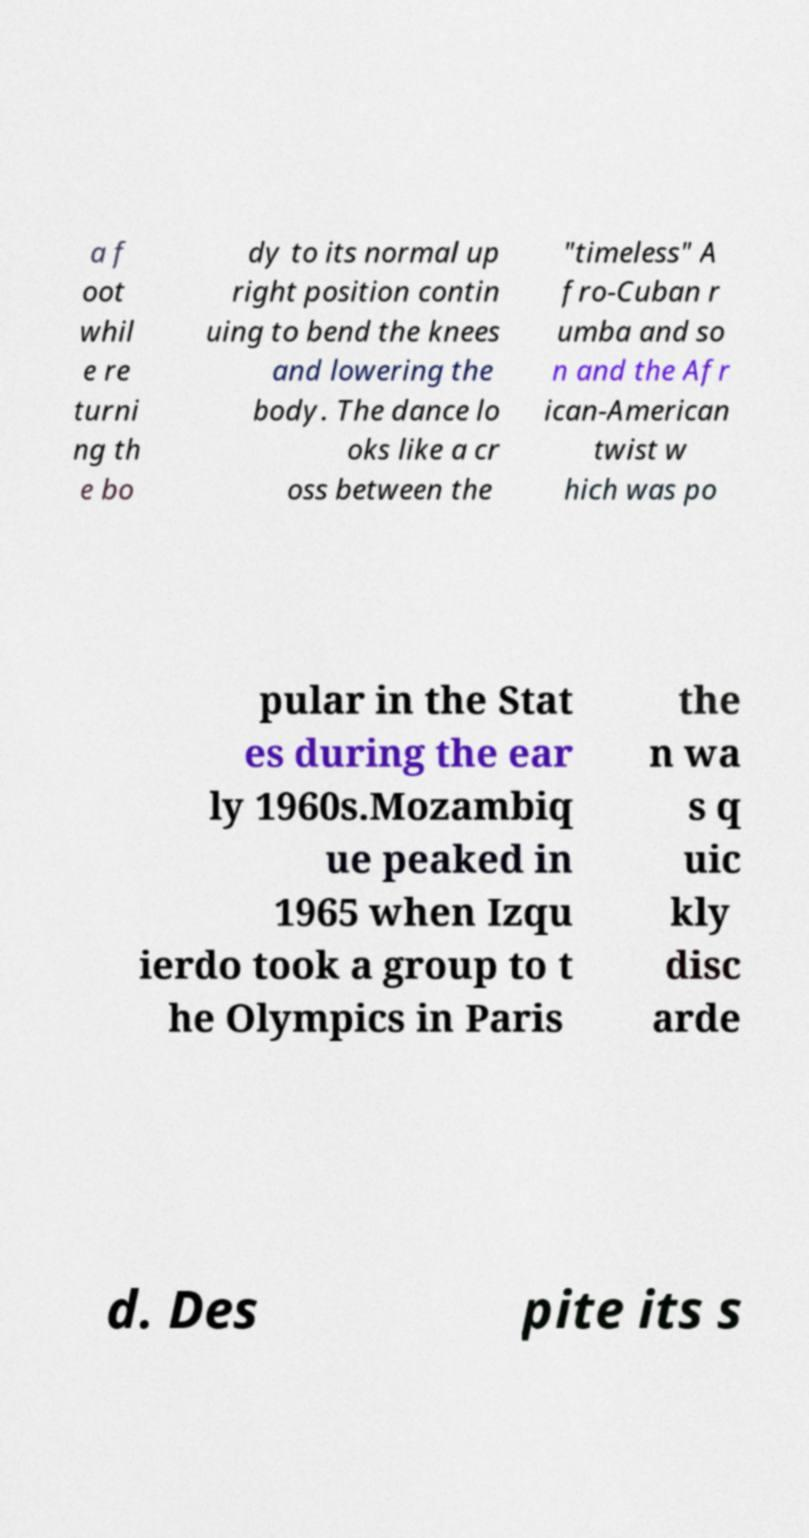There's text embedded in this image that I need extracted. Can you transcribe it verbatim? a f oot whil e re turni ng th e bo dy to its normal up right position contin uing to bend the knees and lowering the body. The dance lo oks like a cr oss between the "timeless" A fro-Cuban r umba and so n and the Afr ican-American twist w hich was po pular in the Stat es during the ear ly 1960s.Mozambiq ue peaked in 1965 when Izqu ierdo took a group to t he Olympics in Paris the n wa s q uic kly disc arde d. Des pite its s 